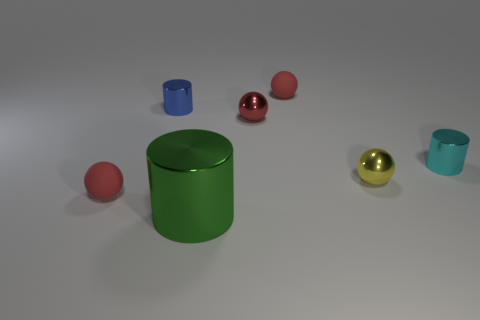Are there an equal number of blue cylinders that are in front of the big shiny thing and tiny red rubber things that are to the right of the small cyan metallic cylinder?
Keep it short and to the point. Yes. What number of things are either gray cubes or small blue shiny things?
Provide a short and direct response. 1. What is the color of the shiny cylinder that is the same size as the blue object?
Ensure brevity in your answer.  Cyan. What number of things are small red matte spheres that are behind the large green metal object or cylinders on the left side of the big metal thing?
Your answer should be compact. 3. Are there the same number of tiny cyan cylinders to the left of the blue metallic thing and tiny red balls?
Offer a terse response. No. Does the cylinder that is left of the green shiny object have the same size as the rubber ball in front of the tiny cyan cylinder?
Ensure brevity in your answer.  Yes. How many other objects are there of the same size as the blue metallic cylinder?
Make the answer very short. 5. Is there a small red rubber thing that is in front of the red matte ball that is behind the small thing that is in front of the yellow sphere?
Make the answer very short. Yes. Is there any other thing that has the same color as the big metallic cylinder?
Ensure brevity in your answer.  No. How big is the rubber thing that is behind the yellow metal sphere?
Your response must be concise. Small. 